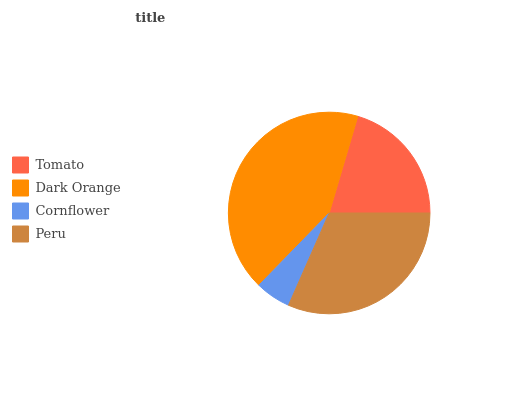Is Cornflower the minimum?
Answer yes or no. Yes. Is Dark Orange the maximum?
Answer yes or no. Yes. Is Dark Orange the minimum?
Answer yes or no. No. Is Cornflower the maximum?
Answer yes or no. No. Is Dark Orange greater than Cornflower?
Answer yes or no. Yes. Is Cornflower less than Dark Orange?
Answer yes or no. Yes. Is Cornflower greater than Dark Orange?
Answer yes or no. No. Is Dark Orange less than Cornflower?
Answer yes or no. No. Is Peru the high median?
Answer yes or no. Yes. Is Tomato the low median?
Answer yes or no. Yes. Is Tomato the high median?
Answer yes or no. No. Is Dark Orange the low median?
Answer yes or no. No. 